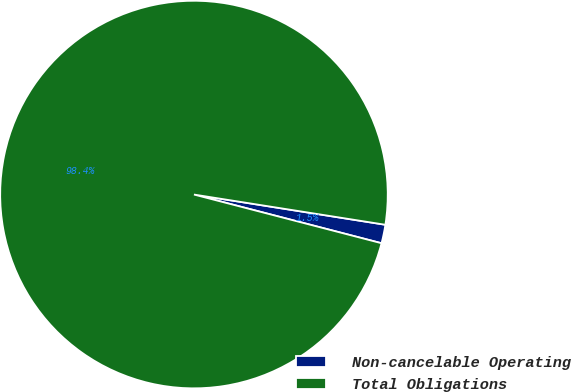Convert chart. <chart><loc_0><loc_0><loc_500><loc_500><pie_chart><fcel>Non-cancelable Operating<fcel>Total Obligations<nl><fcel>1.55%<fcel>98.45%<nl></chart> 